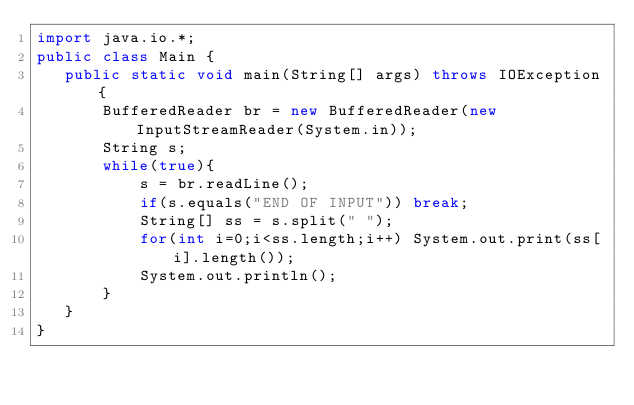Convert code to text. <code><loc_0><loc_0><loc_500><loc_500><_Java_>import java.io.*;
public class Main {
   public static void main(String[] args) throws IOException{
	   BufferedReader br = new BufferedReader(new InputStreamReader(System.in));
	   String s;
	   while(true){
		   s = br.readLine();
		   if(s.equals("END OF INPUT")) break;
		   String[] ss = s.split(" ");
		   for(int i=0;i<ss.length;i++) System.out.print(ss[i].length());
		   System.out.println();
	   }
   }
}</code> 